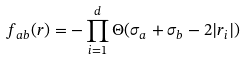<formula> <loc_0><loc_0><loc_500><loc_500>f _ { a b } ( { r } ) = - \prod _ { i = 1 } ^ { d } \Theta ( \sigma _ { a } + \sigma _ { b } - 2 | r _ { i } | )</formula> 